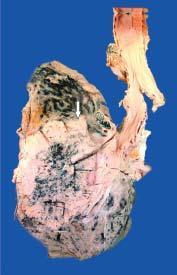does sectioned surface show grey-white fleshy tumour in the bronchus at its bifurcation?
Answer the question using a single word or phrase. Yes 